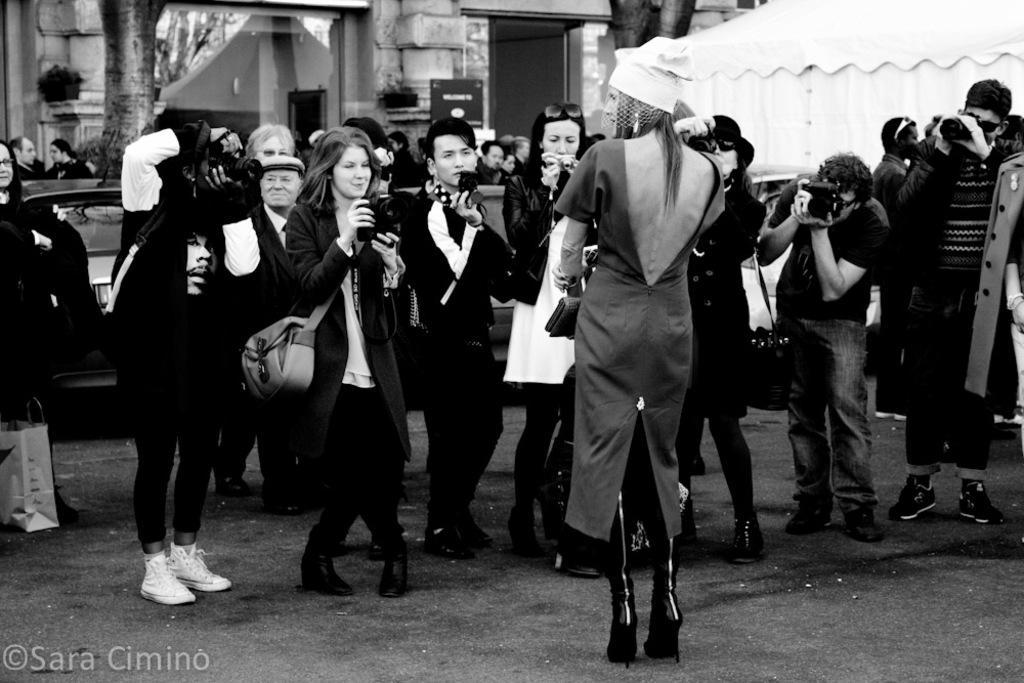Could you give a brief overview of what you see in this image? It is a black and white image, in the middle a beautiful woman is standing. On the left side few people are taking the photographs of her and behind them there is a car. 